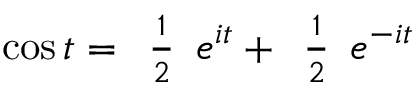<formula> <loc_0><loc_0><loc_500><loc_500>\cos t = { \begin{array} { l } { { \frac { 1 } { 2 } } } \end{array} } e ^ { i t } + { \begin{array} { l } { { \frac { 1 } { 2 } } } \end{array} } e ^ { - i t }</formula> 